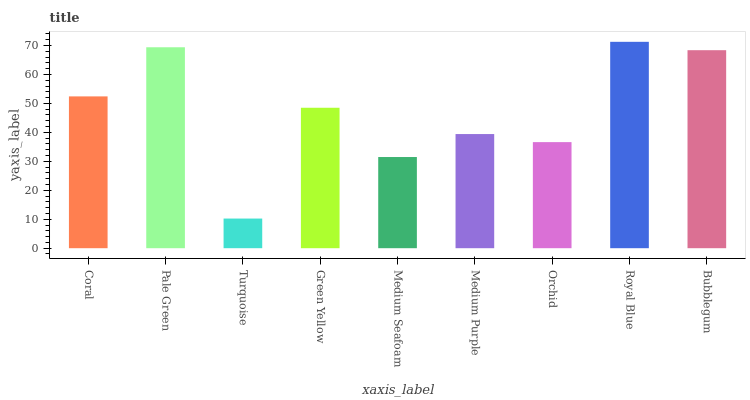Is Turquoise the minimum?
Answer yes or no. Yes. Is Royal Blue the maximum?
Answer yes or no. Yes. Is Pale Green the minimum?
Answer yes or no. No. Is Pale Green the maximum?
Answer yes or no. No. Is Pale Green greater than Coral?
Answer yes or no. Yes. Is Coral less than Pale Green?
Answer yes or no. Yes. Is Coral greater than Pale Green?
Answer yes or no. No. Is Pale Green less than Coral?
Answer yes or no. No. Is Green Yellow the high median?
Answer yes or no. Yes. Is Green Yellow the low median?
Answer yes or no. Yes. Is Medium Purple the high median?
Answer yes or no. No. Is Pale Green the low median?
Answer yes or no. No. 